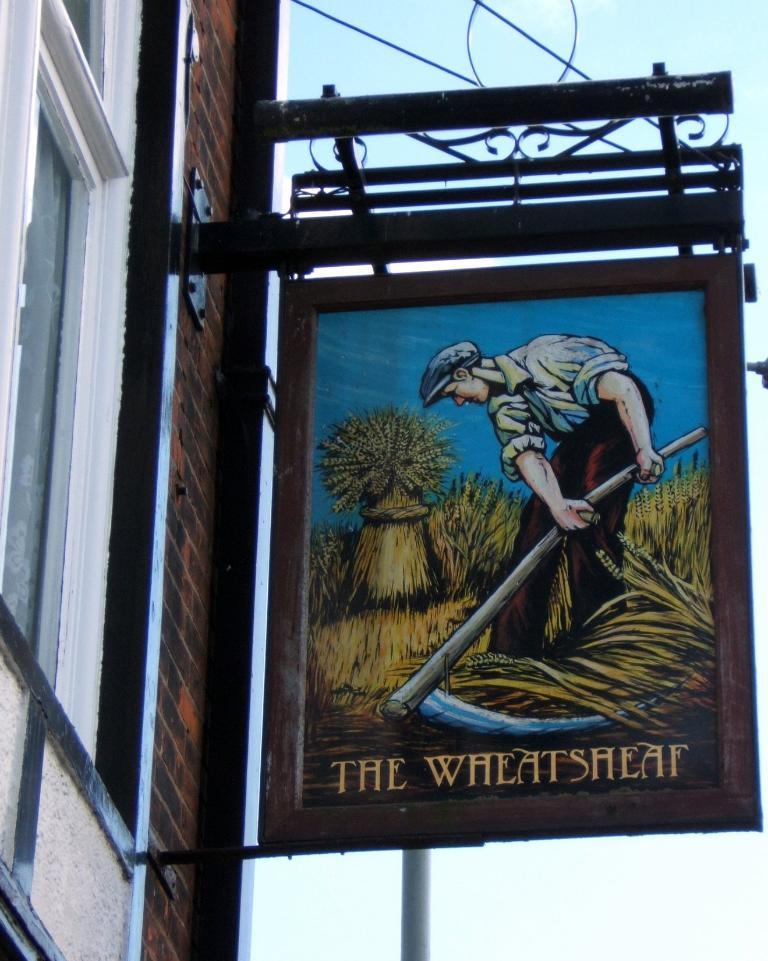What structure can be seen in the image? There is a building in the image. What is attached to the building? There is a hoarding attached to the building. What is the person on the hoarding doing? The person is standing on the hoarding. What object is the person holding? The person is holding a sword in his hand. What type of development can be seen in the image? There is no development project or construction site visible in the image; it features a building with a hoarding and a person standing on it holding a sword. 